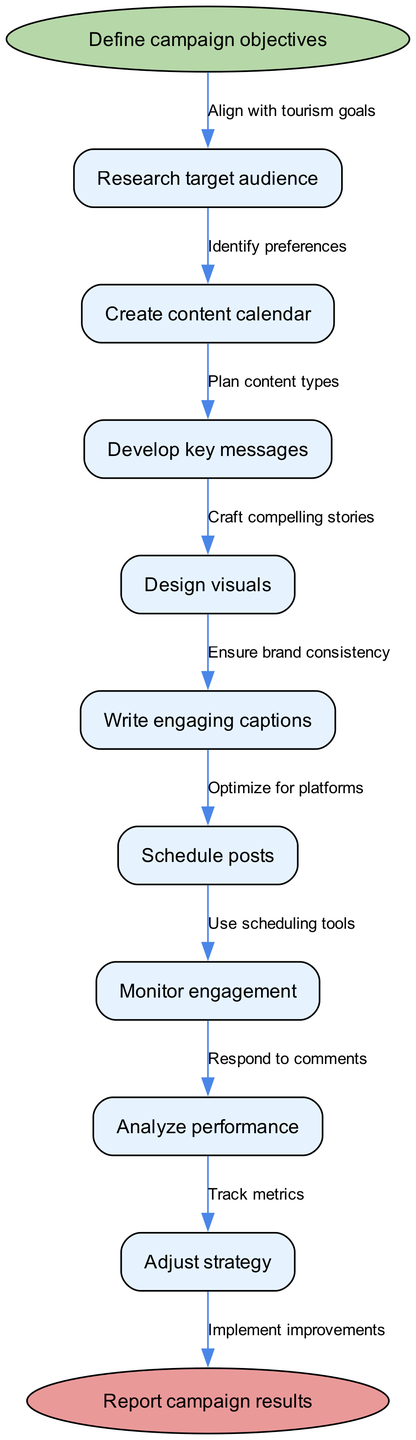What is the starting node of the workflow? The starting node is explicitly labeled as "Define campaign objectives" in the diagram.
Answer: Define campaign objectives How many nodes are present in the diagram? By counting all the nodes listed under "nodes," there are a total of 9 nodes including the start and end nodes.
Answer: 9 What is the end node of the workflow? The end node is labeled as "Report campaign results" in the diagram, clearly indicating where the process concludes.
Answer: Report campaign results Which node comes after "Research target audience"? The diagram shows that "Create content calendar" is directly connected to "Research target audience," meaning it follows it in the workflow.
Answer: Create content calendar What is the relationship between "Analyze performance" and "Adjust strategy"? The diagram indicates a direct edge from "Analyze performance" to "Adjust strategy," showing that performance analysis leads to adjustments in strategy.
Answer: Performance analysis leads to adjustments What type of messages are developed before designing visuals? According to the flow, "Develop key messages" is the node that precedes "Design visuals," indicating that messages must be crafted first.
Answer: Develop key messages How many edges are there in total connecting the nodes? The diagram illustrates 8 edges connecting the nodes, as each transition between nodes adds an edge, and there are 8 connections in total.
Answer: 8 What is the concluding action after monitoring engagement? The process flows from "Monitor engagement" to "Analyze performance," thus indicating that analyzing performance is the next step after monitoring.
Answer: Analyze performance What action is taken to respond to engagement from followers? "Respond to comments" is listed as a key action that should take place after monitoring engagement, indicating that interaction is expected.
Answer: Respond to comments 